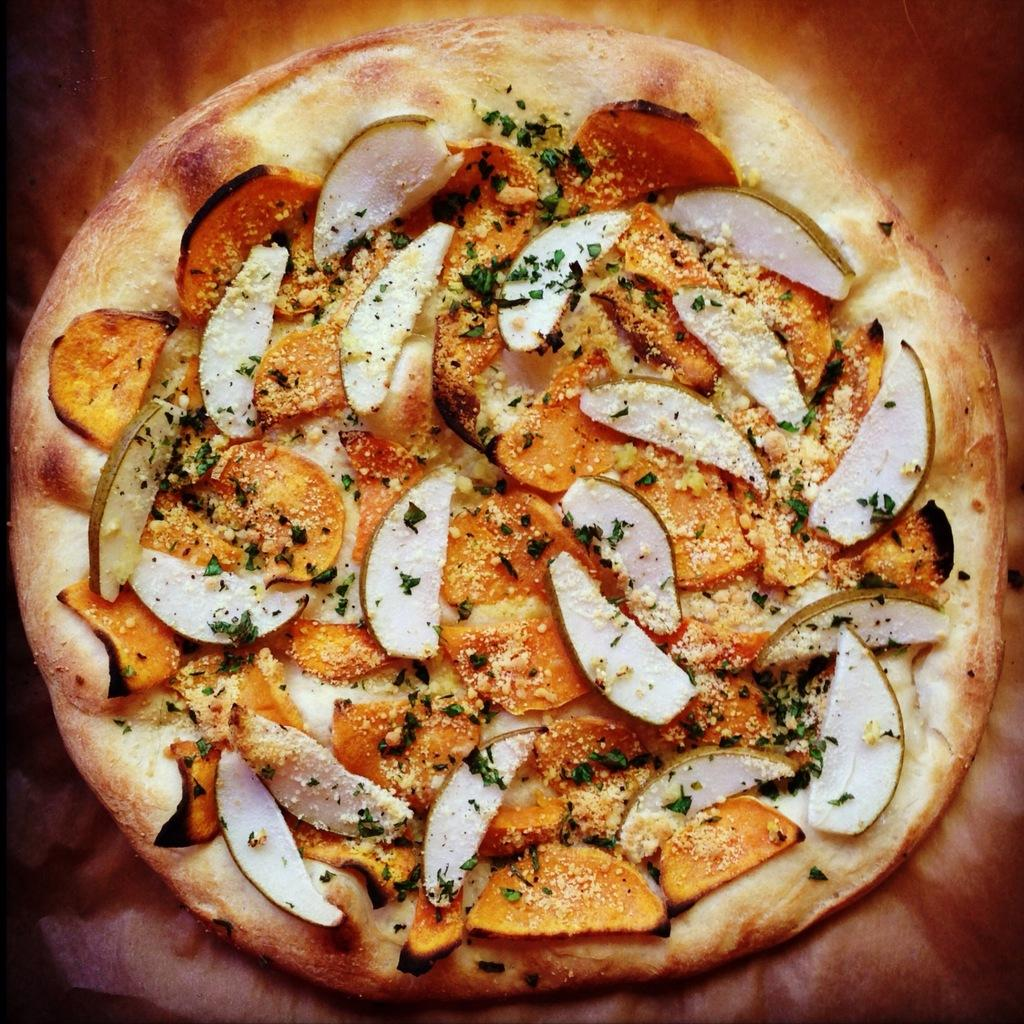What is the main subject of the image? There is a food item in the image. What type of ingredients can be seen in the food item? The food item has vegetable slices. Can you describe the background of the image? The background of the image is blurred. What type of weather can be seen in the image? There is no weather visible in the image, as it focuses on a food item with vegetable slices and a blurred background. 